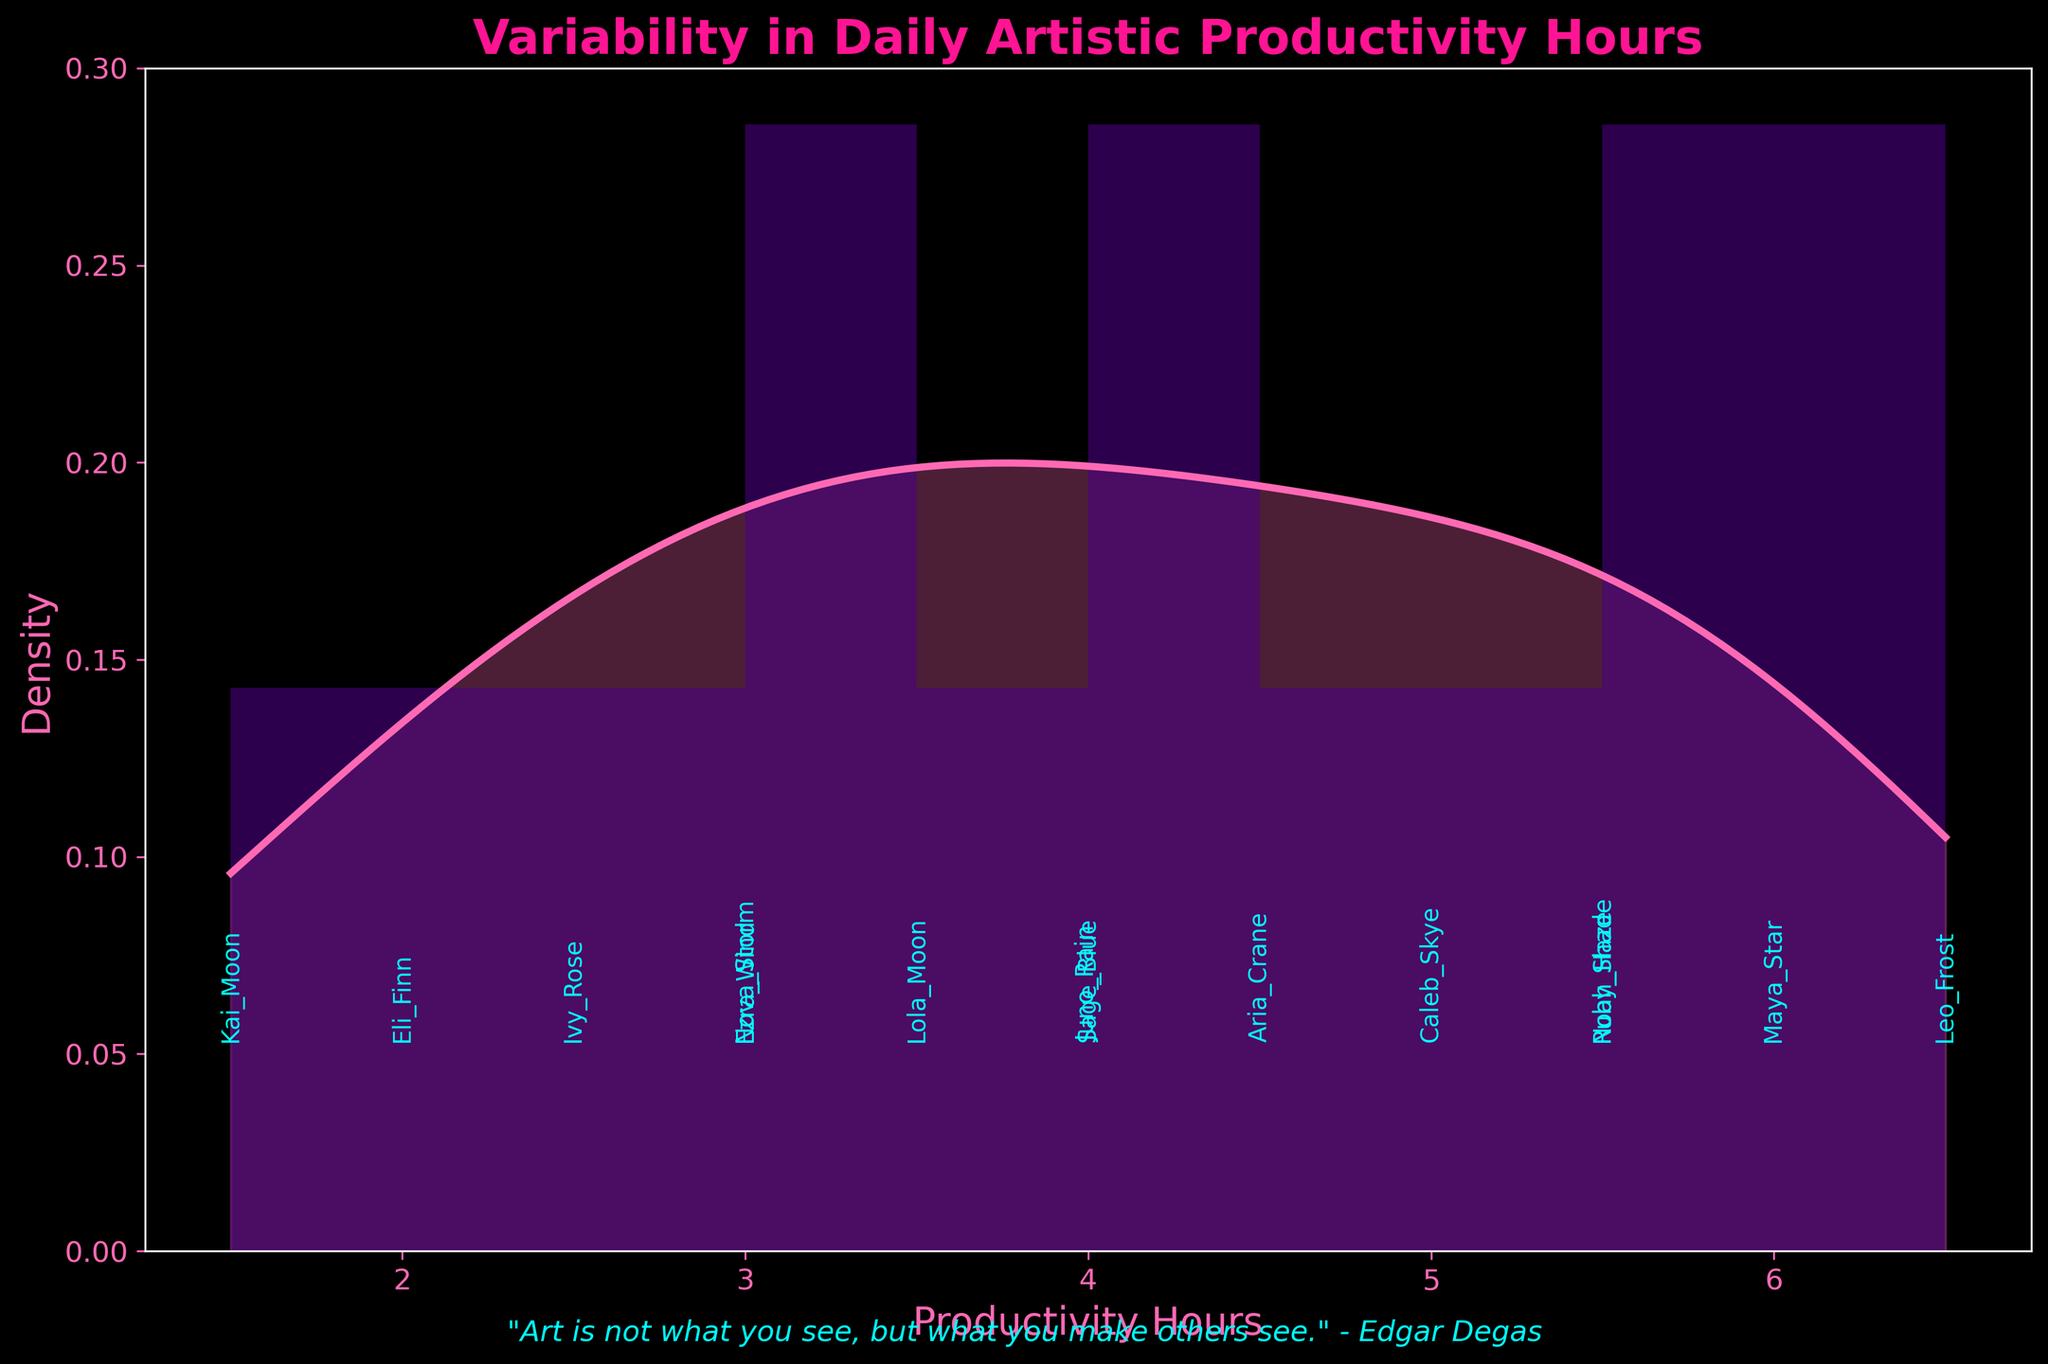What is the title of the plot? The title is usually found at the top of the plot and gives a brief description of what the plot is about. Here, it reads "Variability in Daily Artistic Productivity Hours."
Answer: Variability in Daily Artistic Productivity Hours What do the x-axis and y-axis represent? The labels on the axes explain what each axis represents. The x-axis is labeled "Productivity Hours" and the y-axis is labeled "Density."
Answer: Productivity Hours and Density How many artists are shown in this plot? Each bin in the histogram usually represents individual data points. Since there are annotations with artist names for each point, counting these unique names will give us the number of artists.
Answer: 14 Which artist has the maximum productivity hours? From the annotations and bins, we can spot that "Leo_Frost" is positioned at 6.5 hours, the highest on the x-axis.
Answer: Leo_Frost What is the average productivity hours of the artists? Sum the productivity hours for all artists and then divide by the number of artists. (3.5 + 5.0 + 4.0 + 2.0 + 6.0 + 3.0 + 4.5 + 5.5 + 2.5 + 6.5 + 3.0 + 1.5 + 4.0 + 5.5) / 14 = 4.14
Answer: 4.14 How many productivity hours did the artist with the lowest productivity record? By checking the x-axis and annotations, "Kai_Moon" is at 1.5, the lowest recorded productivity hours.
Answer: 1.5 What's the density value at 4.5 productivity hours? Observing the plot, the y-value at 4.5 productivity hours on the KDE curve indicates the density, approximately around 0.12.
Answer: ~0.12 Compare the productivity hours of Maya_Star and Ivy_Rose. Who is more productive? Maya_Star is located at 6.0 hours and Ivy_Rose at 2.5 hours on the x-axis. Clearly, Maya_Star is more productive.
Answer: Maya_Star What range of productivity hours is most common among the artists? Judge the tallest bins in the histogram. The bins around 3.5 to 4.5 hours appear to be the highest, indicating the most common range.
Answer: 3.5 to 4.5 Is there any artist with exactly 5.5 productivity hours, and if so, who are they? From the annotations above the bins, we see "Noah_Haze" and "Ruby_Shade" both at 5.5 hours.
Answer: Noah_Haze, Ruby_Shade 